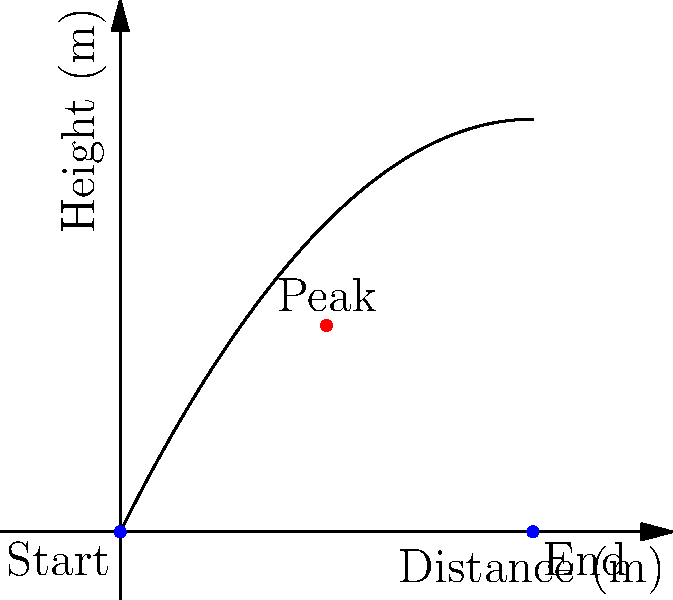Look at the graph showing the path of a basketball shot. The horizontal axis represents the distance traveled, and the vertical axis represents the height of the ball. If the ball travels a total horizontal distance of 10 meters, what is the maximum height reached by the ball? To find the maximum height of the basketball shot, we need to follow these steps:

1. Understand the graph: The curve represents the path of the basketball, with distance on the x-axis and height on the y-axis.

2. Identify the peak: The highest point of the curve represents the maximum height of the ball.

3. Locate the peak: The peak appears to be at the point (5, 5) on the graph.

4. Read the y-coordinate: The y-coordinate of the peak point represents the maximum height.

5. Interpret the result: The y-coordinate at the peak is 5, which means the maximum height reached by the ball is 5 meters.

Remember, in physics, the path of a projectile (like a basketball) typically follows a parabolic curve, which is what we see in this graph. The highest point of this parabola represents the maximum height of the ball's trajectory.
Answer: 5 meters 